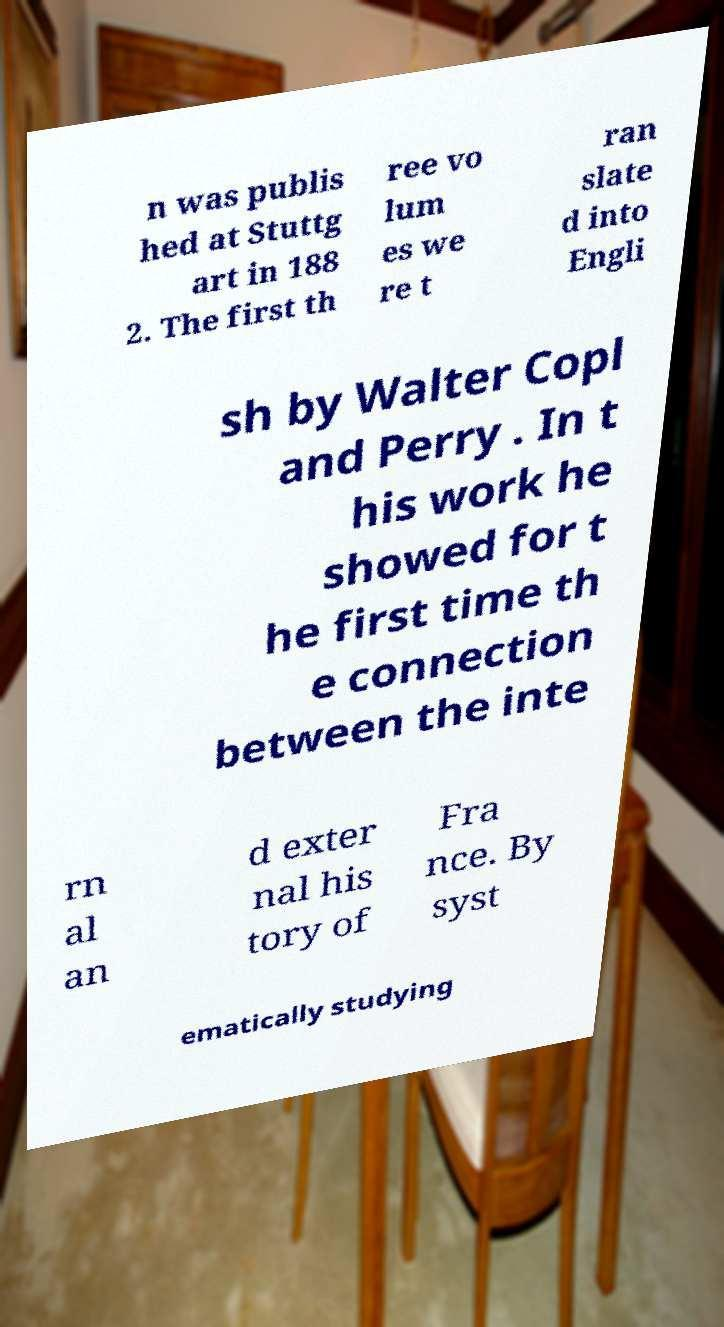What messages or text are displayed in this image? I need them in a readable, typed format. n was publis hed at Stuttg art in 188 2. The first th ree vo lum es we re t ran slate d into Engli sh by Walter Copl and Perry . In t his work he showed for t he first time th e connection between the inte rn al an d exter nal his tory of Fra nce. By syst ematically studying 